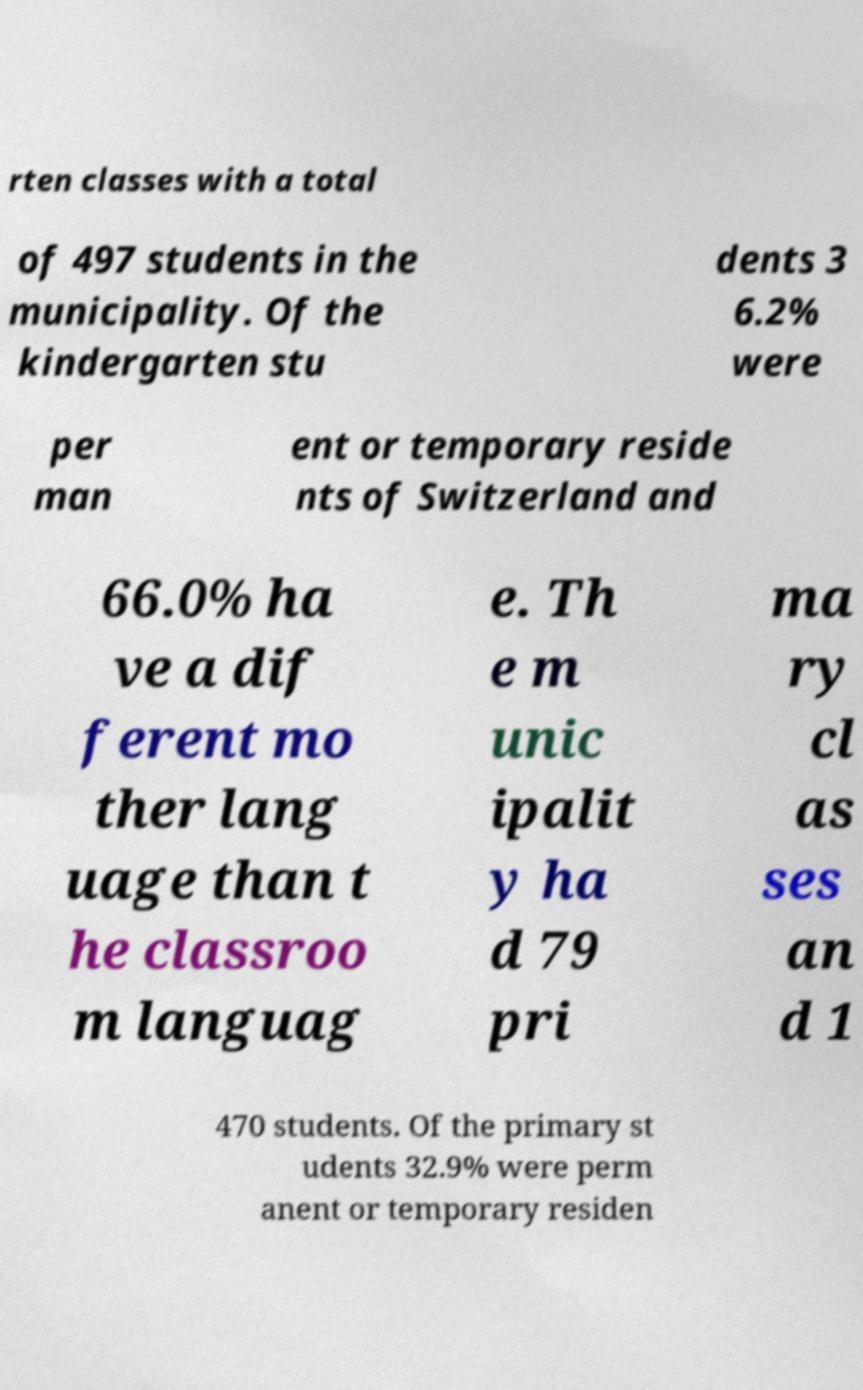Could you assist in decoding the text presented in this image and type it out clearly? rten classes with a total of 497 students in the municipality. Of the kindergarten stu dents 3 6.2% were per man ent or temporary reside nts of Switzerland and 66.0% ha ve a dif ferent mo ther lang uage than t he classroo m languag e. Th e m unic ipalit y ha d 79 pri ma ry cl as ses an d 1 470 students. Of the primary st udents 32.9% were perm anent or temporary residen 